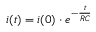Convert formula to latex. <formula><loc_0><loc_0><loc_500><loc_500>i ( t ) = i ( 0 ) \cdot e ^ { - \frac { t } { R C } }</formula> 